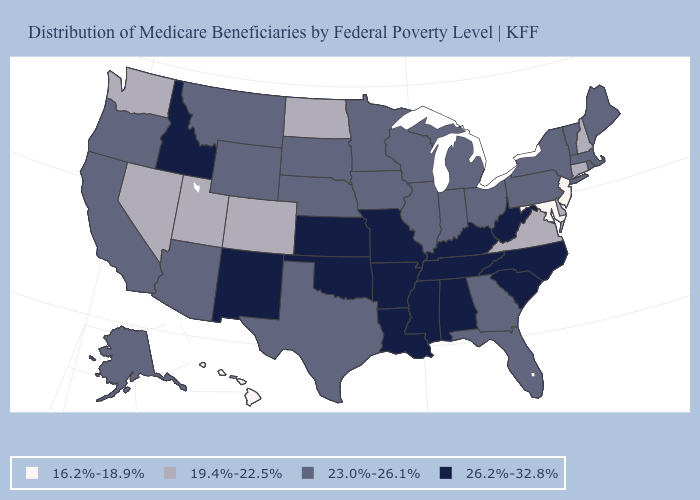What is the lowest value in the West?
Answer briefly. 16.2%-18.9%. Which states have the lowest value in the USA?
Be succinct. Hawaii, Maryland, New Jersey. Name the states that have a value in the range 16.2%-18.9%?
Short answer required. Hawaii, Maryland, New Jersey. What is the highest value in the USA?
Keep it brief. 26.2%-32.8%. What is the value of Virginia?
Give a very brief answer. 19.4%-22.5%. What is the value of Oklahoma?
Give a very brief answer. 26.2%-32.8%. What is the highest value in the South ?
Give a very brief answer. 26.2%-32.8%. Does the first symbol in the legend represent the smallest category?
Keep it brief. Yes. Does New Hampshire have the highest value in the Northeast?
Write a very short answer. No. What is the value of Oregon?
Give a very brief answer. 23.0%-26.1%. What is the value of New Hampshire?
Concise answer only. 19.4%-22.5%. How many symbols are there in the legend?
Short answer required. 4. Is the legend a continuous bar?
Keep it brief. No. What is the lowest value in the South?
Concise answer only. 16.2%-18.9%. What is the value of New Hampshire?
Write a very short answer. 19.4%-22.5%. 